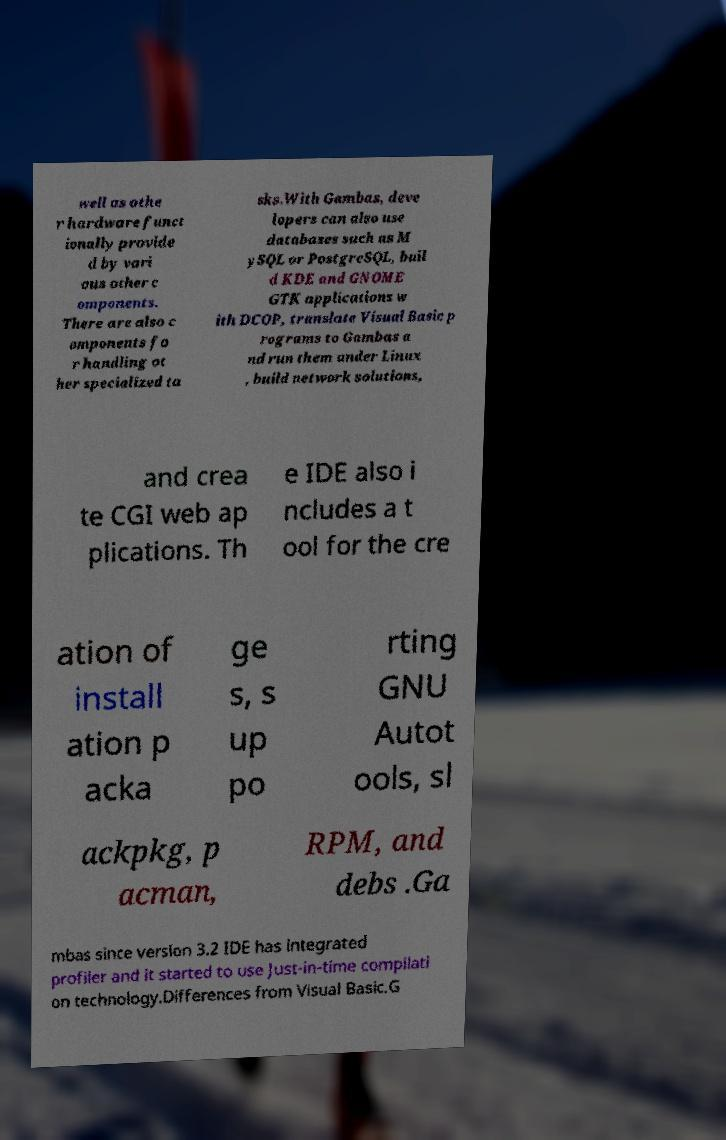Please identify and transcribe the text found in this image. well as othe r hardware funct ionally provide d by vari ous other c omponents. There are also c omponents fo r handling ot her specialized ta sks.With Gambas, deve lopers can also use databases such as M ySQL or PostgreSQL, buil d KDE and GNOME GTK applications w ith DCOP, translate Visual Basic p rograms to Gambas a nd run them under Linux , build network solutions, and crea te CGI web ap plications. Th e IDE also i ncludes a t ool for the cre ation of install ation p acka ge s, s up po rting GNU Autot ools, sl ackpkg, p acman, RPM, and debs .Ga mbas since version 3.2 IDE has integrated profiler and it started to use Just-in-time compilati on technology.Differences from Visual Basic.G 